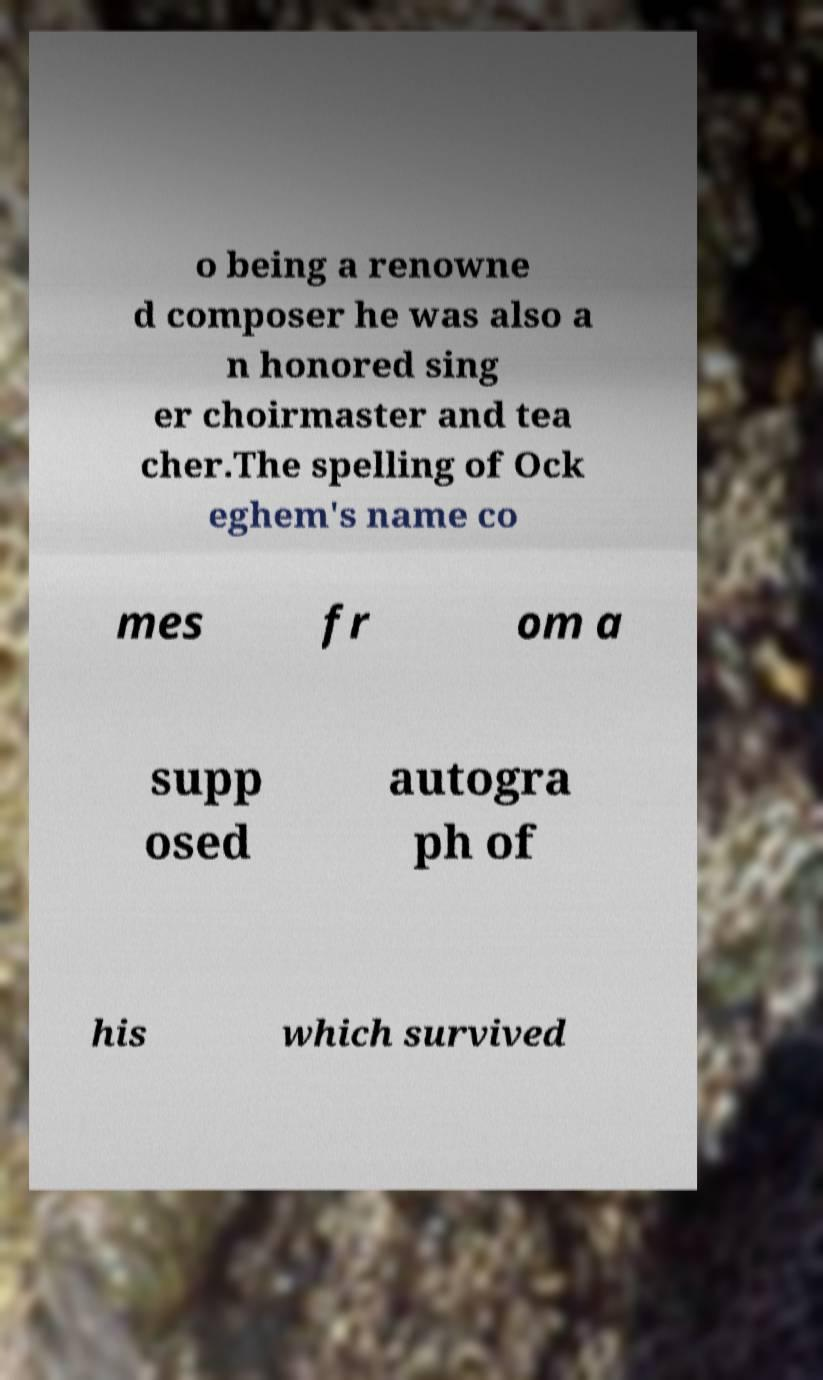I need the written content from this picture converted into text. Can you do that? o being a renowne d composer he was also a n honored sing er choirmaster and tea cher.The spelling of Ock eghem's name co mes fr om a supp osed autogra ph of his which survived 